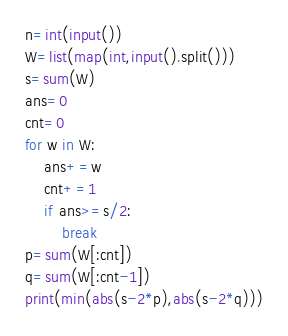Convert code to text. <code><loc_0><loc_0><loc_500><loc_500><_Python_>n=int(input())
W=list(map(int,input().split()))
s=sum(W)
ans=0
cnt=0
for w in W:
    ans+=w
    cnt+=1
    if ans>=s/2:
        break
p=sum(W[:cnt])
q=sum(W[:cnt-1])
print(min(abs(s-2*p),abs(s-2*q)))</code> 